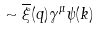<formula> <loc_0><loc_0><loc_500><loc_500>\sim \overline { \xi } ( q ) \gamma ^ { \mu } \psi ( k )</formula> 